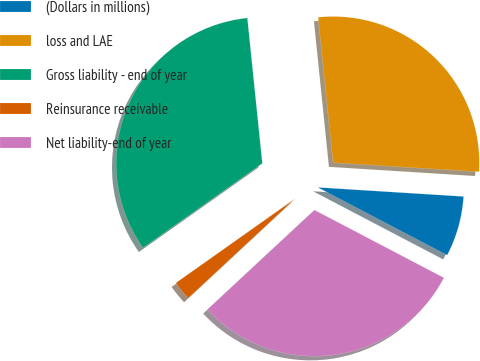Convert chart to OTSL. <chart><loc_0><loc_0><loc_500><loc_500><pie_chart><fcel>(Dollars in millions)<fcel>loss and LAE<fcel>Gross liability - end of year<fcel>Reinsurance receivable<fcel>Net liability-end of year<nl><fcel>6.68%<fcel>27.63%<fcel>33.16%<fcel>2.13%<fcel>30.4%<nl></chart> 